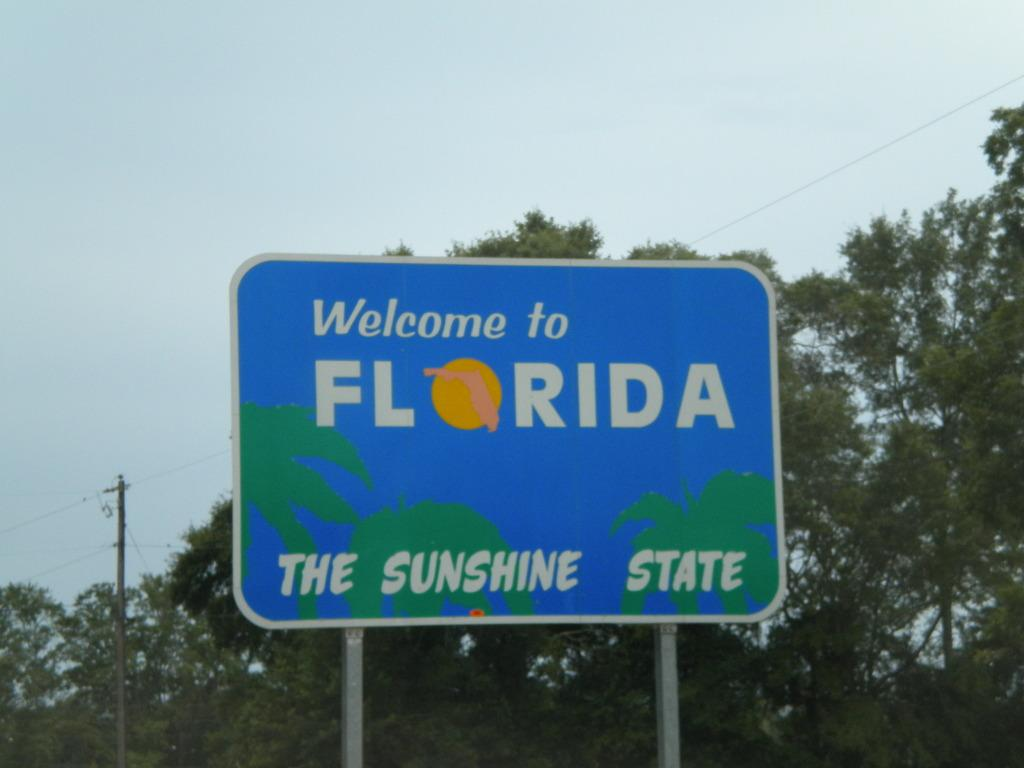<image>
Describe the image concisely. A sign reading Welcome to Florida, the Sunshine State. 